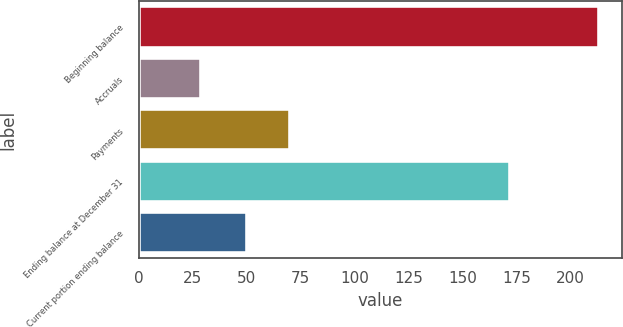Convert chart. <chart><loc_0><loc_0><loc_500><loc_500><bar_chart><fcel>Beginning balance<fcel>Accruals<fcel>Payments<fcel>Ending balance at December 31<fcel>Current portion ending balance<nl><fcel>213<fcel>29<fcel>70<fcel>172<fcel>50<nl></chart> 